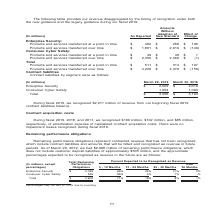According to Nortonlifelock's financial document, As of March 29, 2019, how much remaining performance obligations are there? According to the financial document, $2,608 million. The relevant text states: "ue in future periods. As of March 29, 2019, we had $2,608 million of remaining performance obligations, which does not include customer deposit liabilities of approxi..." Also, What is the Total Remaining Performance Obligations for Enterprise Security? According to the financial document, 2,059 (in millions). The relevant text states: "Enterprise Security $ 2,059 65% 24% 10% 2% Consumer Cyber Safety 549 95% 4% 1% -%..." Also, What is the Total Remaining Performance Obligations for Consumer Cyber Safety? According to the financial document, 549 (in millions). The relevant text states: "rity $ 2,059 65% 24% 10% 2% Consumer Cyber Safety 549 95% 4% 1% -%..." Also, can you calculate: What is the percentage constitution of the Total Remaining Performance Obligations of Consumer Cyber Safety among the total remaining performance obligations? Based on the calculation: 549/2,608, the result is 21.05 (percentage). This is based on the information: "in future periods. As of March 29, 2019, we had $2,608 million of remaining performance obligations, which does not include customer deposit liabilities o rity $ 2,059 65% 24% 10% 2% Consumer Cyber Sa..." The key data points involved are: 2,608, 549. Also, can you calculate: What is the difference in Total Remaining Performance Obligations for Consumer Cyber Safety and Enterprise Security? Based on the calculation: 2,059-549, the result is 1510 (in millions). This is based on the information: "Enterprise Security $ 2,059 65% 24% 10% 2% Consumer Cyber Safety 549 95% 4% 1% -% rity $ 2,059 65% 24% 10% 2% Consumer Cyber Safety 549 95% 4% 1% -%..." The key data points involved are: 2,059, 549. Also, can you calculate: What is Total Remaining Performance Obligations for Enterprise Security expressed as a percentage of total obligations? Based on the calculation: 2,059/2,608, the result is 78.95 (percentage). This is based on the information: "Enterprise Security $ 2,059 65% 24% 10% 2% Consumer Cyber Safety 549 95% 4% 1% -% in future periods. As of March 29, 2019, we had $2,608 million of remaining performance obligations, which does not in..." The key data points involved are: 2,059, 2,608. 